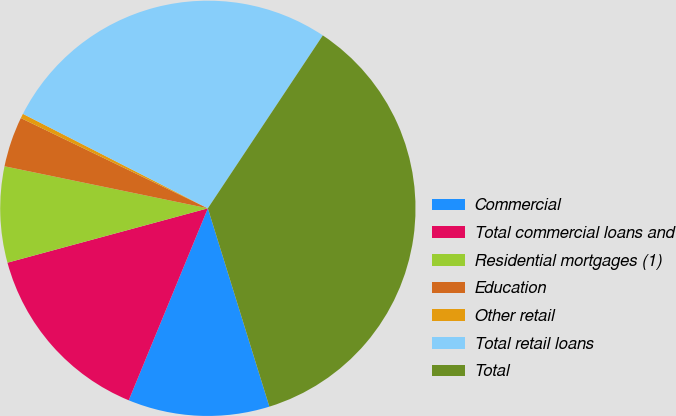<chart> <loc_0><loc_0><loc_500><loc_500><pie_chart><fcel>Commercial<fcel>Total commercial loans and<fcel>Residential mortgages (1)<fcel>Education<fcel>Other retail<fcel>Total retail loans<fcel>Total<nl><fcel>11.01%<fcel>14.56%<fcel>7.46%<fcel>3.91%<fcel>0.36%<fcel>26.82%<fcel>35.87%<nl></chart> 